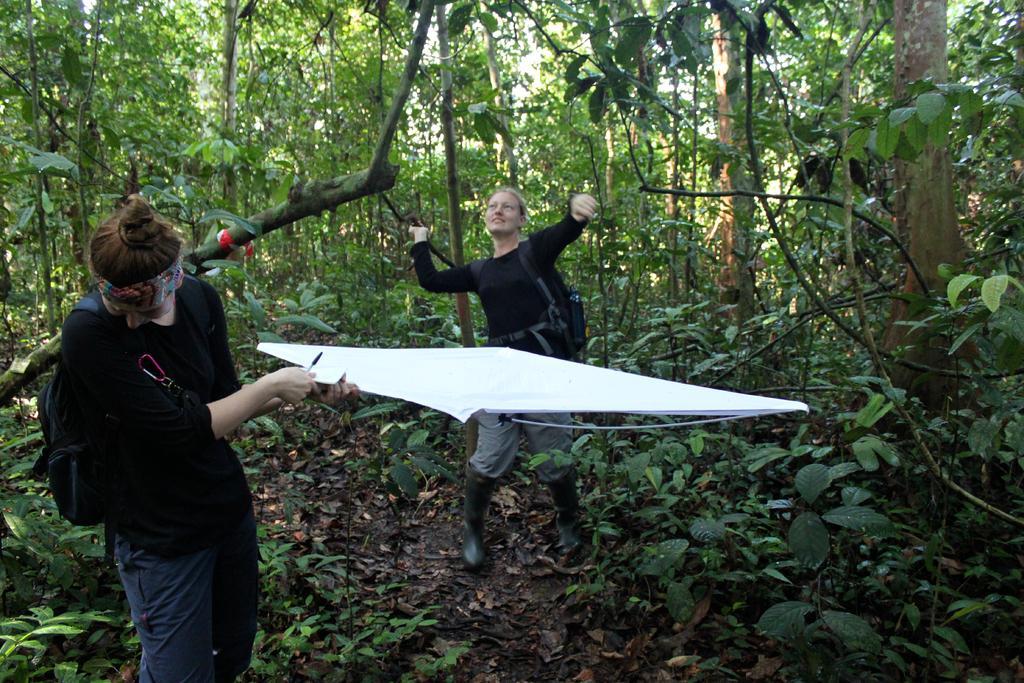Can you describe this image briefly? In this picture I can see two persons standing and holding some objects. I can see plants, and in the background there are trees and the sky. 